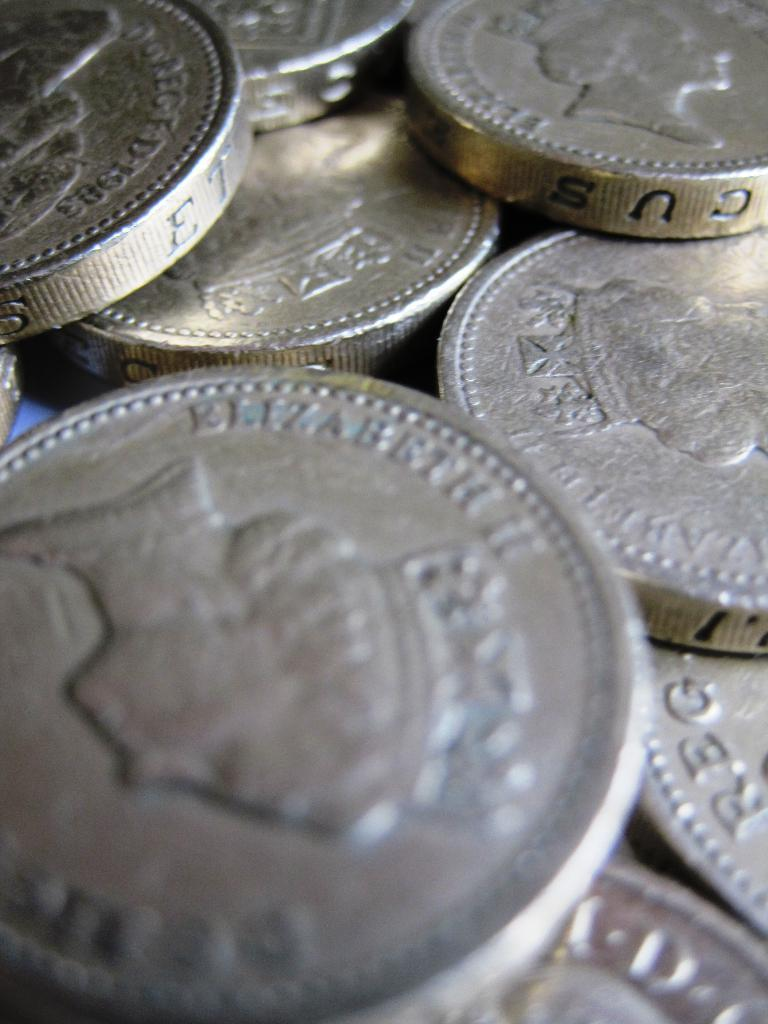<image>
Present a compact description of the photo's key features. Many coins on a table including one that says CUS on the side. 